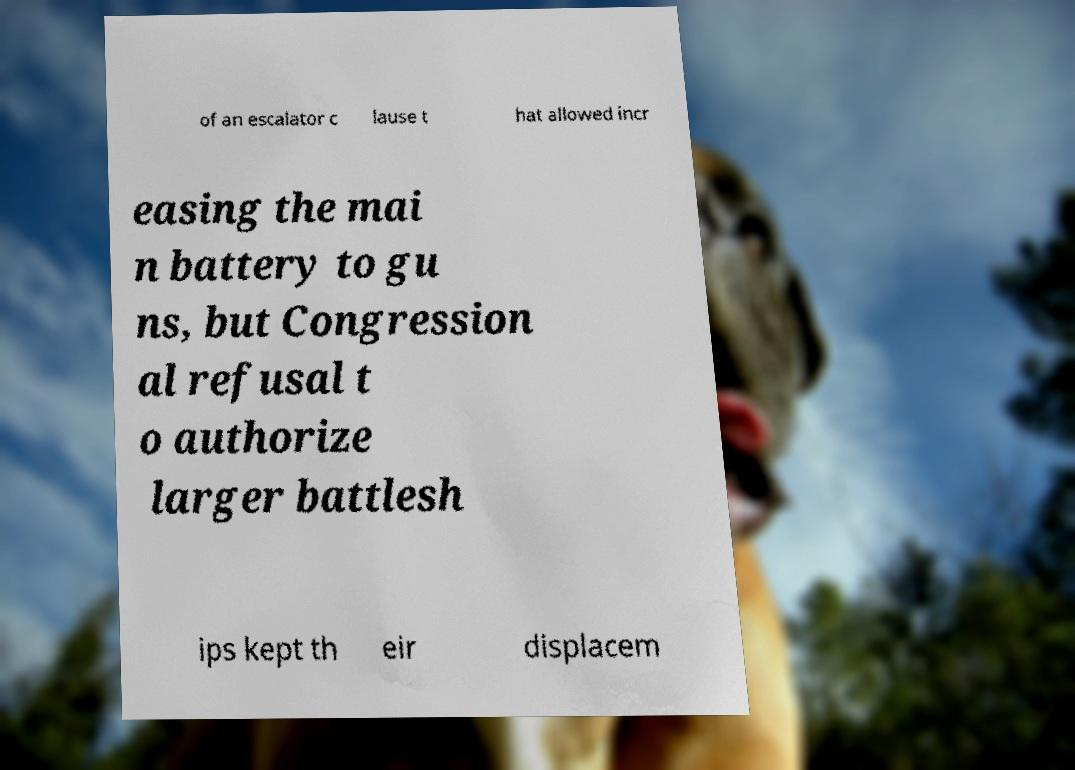For documentation purposes, I need the text within this image transcribed. Could you provide that? of an escalator c lause t hat allowed incr easing the mai n battery to gu ns, but Congression al refusal t o authorize larger battlesh ips kept th eir displacem 